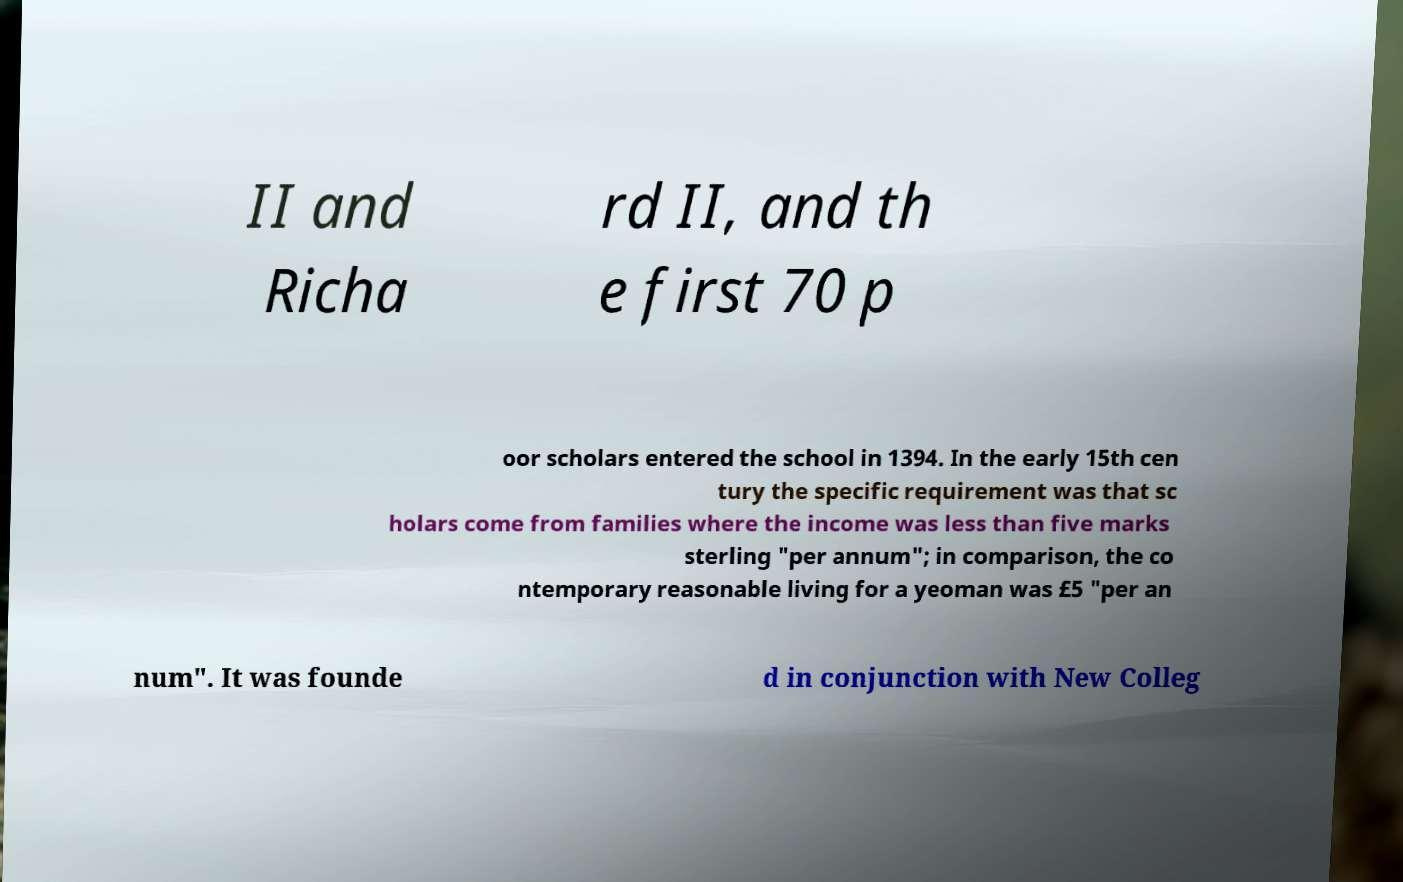Could you extract and type out the text from this image? II and Richa rd II, and th e first 70 p oor scholars entered the school in 1394. In the early 15th cen tury the specific requirement was that sc holars come from families where the income was less than five marks sterling "per annum"; in comparison, the co ntemporary reasonable living for a yeoman was £5 "per an num". It was founde d in conjunction with New Colleg 